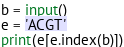<code> <loc_0><loc_0><loc_500><loc_500><_Python_>b = input()
e = 'ACGT'
print(e[e.index(b)])</code> 